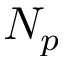<formula> <loc_0><loc_0><loc_500><loc_500>N _ { p }</formula> 